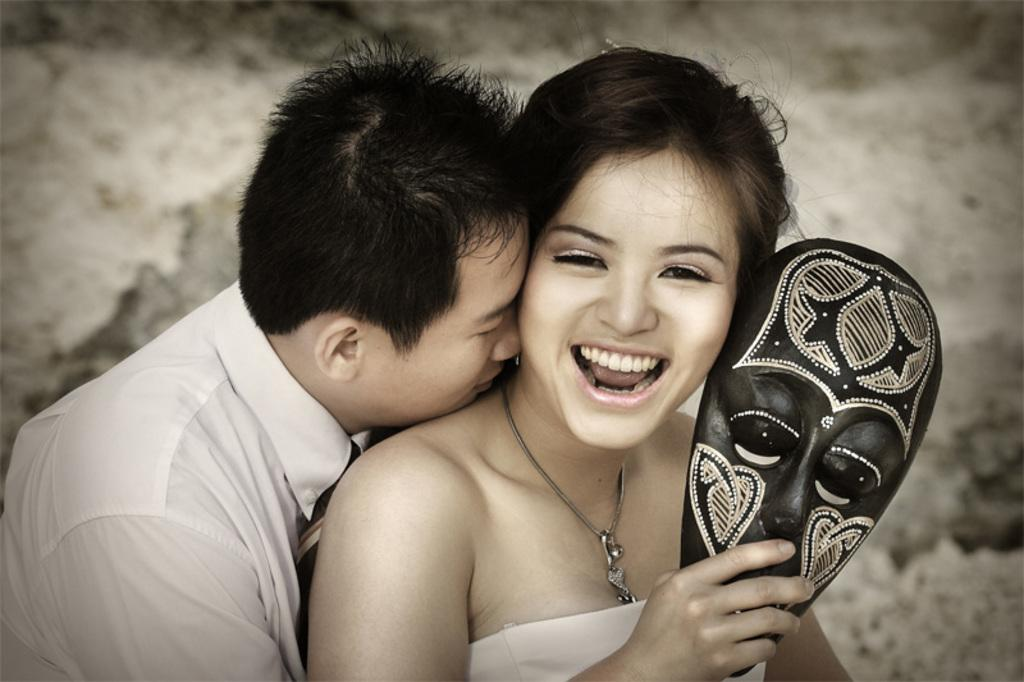How many people are in the image? There are two people in the image. Can you describe the gender of one of the individuals? One of the people is a woman. What is the woman holding in her hand? The woman is holding a face mask in her hand. Can you describe the attire of the other person? The other person is a man, and he is wearing a tie. What type of silk is being used to make the cream in the image? There is no silk or cream present in the image. What type of knowledge is being shared between the two people in the image? The image does not provide any information about the knowledge being shared between the two people. 